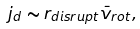Convert formula to latex. <formula><loc_0><loc_0><loc_500><loc_500>j _ { d } \sim r _ { d i s r u p t } \bar { v } _ { r o t } ,</formula> 